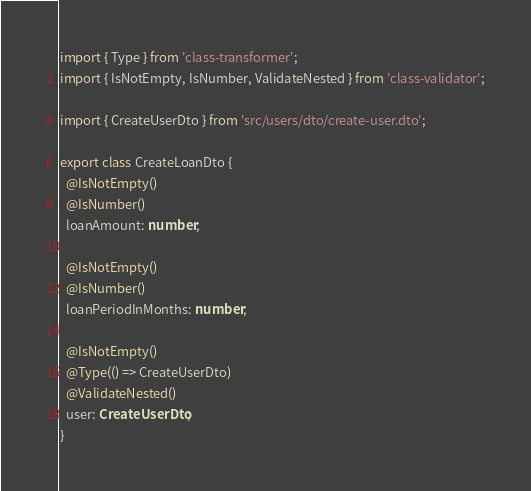Convert code to text. <code><loc_0><loc_0><loc_500><loc_500><_TypeScript_>import { Type } from 'class-transformer';
import { IsNotEmpty, IsNumber, ValidateNested } from 'class-validator';

import { CreateUserDto } from 'src/users/dto/create-user.dto';

export class CreateLoanDto {
  @IsNotEmpty()
  @IsNumber()
  loanAmount: number;

  @IsNotEmpty()
  @IsNumber()
  loanPeriodInMonths: number;

  @IsNotEmpty()
  @Type(() => CreateUserDto)
  @ValidateNested()
  user: CreateUserDto;
}
</code> 